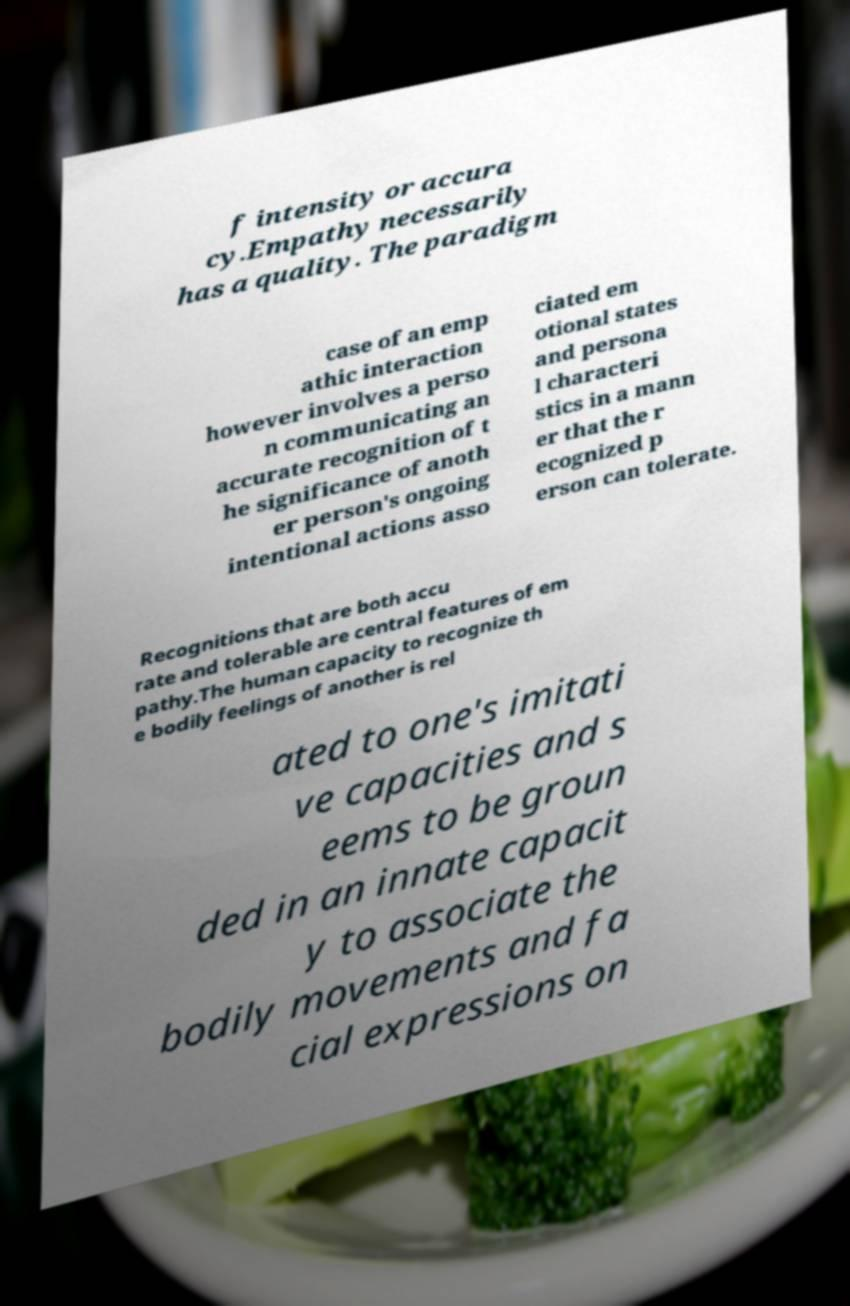I need the written content from this picture converted into text. Can you do that? f intensity or accura cy.Empathy necessarily has a quality. The paradigm case of an emp athic interaction however involves a perso n communicating an accurate recognition of t he significance of anoth er person's ongoing intentional actions asso ciated em otional states and persona l characteri stics in a mann er that the r ecognized p erson can tolerate. Recognitions that are both accu rate and tolerable are central features of em pathy.The human capacity to recognize th e bodily feelings of another is rel ated to one's imitati ve capacities and s eems to be groun ded in an innate capacit y to associate the bodily movements and fa cial expressions on 